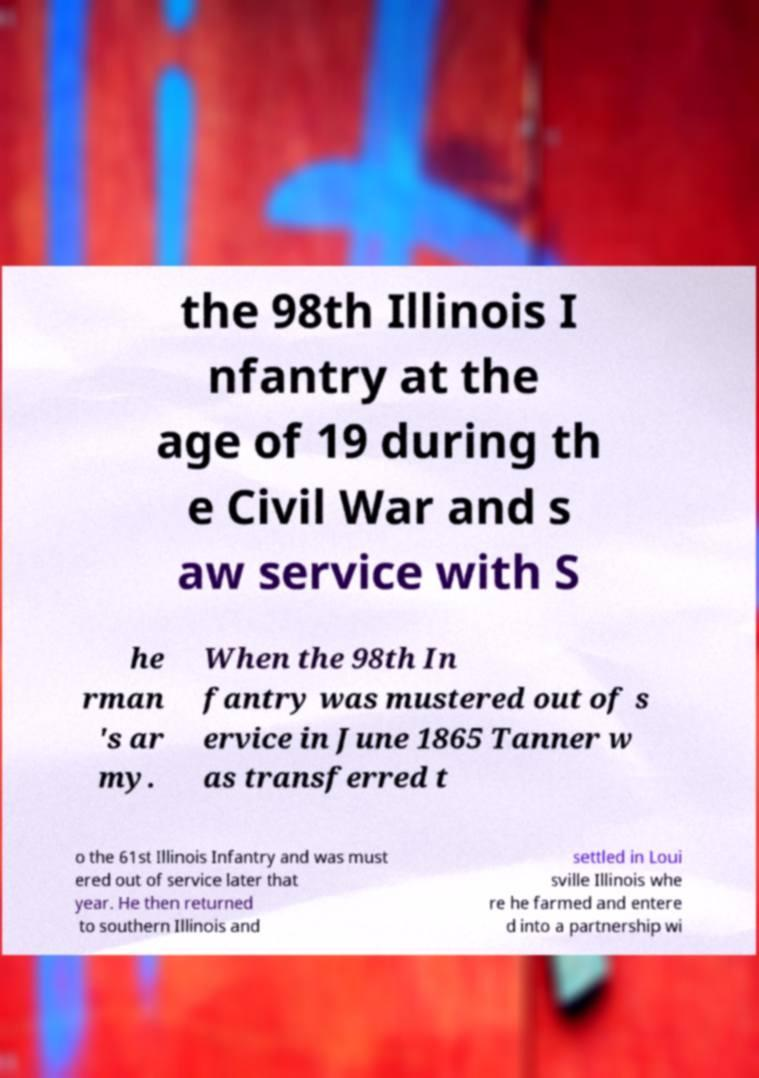Can you accurately transcribe the text from the provided image for me? the 98th Illinois I nfantry at the age of 19 during th e Civil War and s aw service with S he rman 's ar my. When the 98th In fantry was mustered out of s ervice in June 1865 Tanner w as transferred t o the 61st Illinois Infantry and was must ered out of service later that year. He then returned to southern Illinois and settled in Loui sville Illinois whe re he farmed and entere d into a partnership wi 